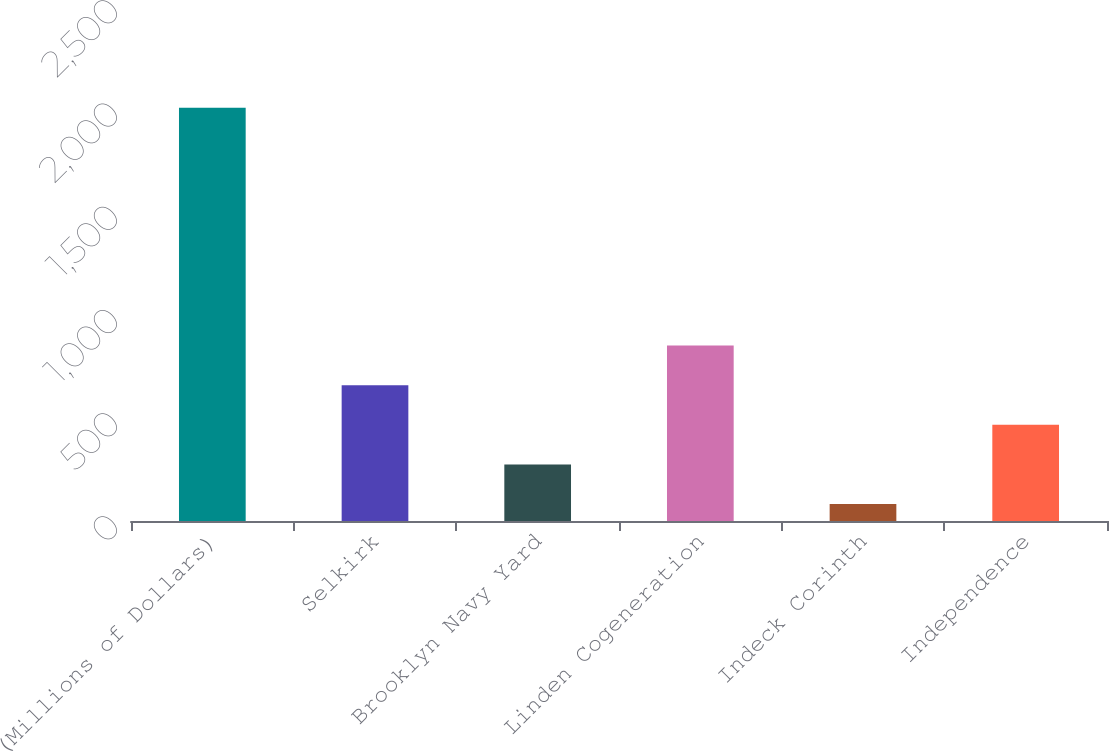Convert chart to OTSL. <chart><loc_0><loc_0><loc_500><loc_500><bar_chart><fcel>(Millions of Dollars)<fcel>Selkirk<fcel>Brooklyn Navy Yard<fcel>Linden Cogeneration<fcel>Indeck Corinth<fcel>Independence<nl><fcel>2002<fcel>658<fcel>274<fcel>850<fcel>82<fcel>466<nl></chart> 